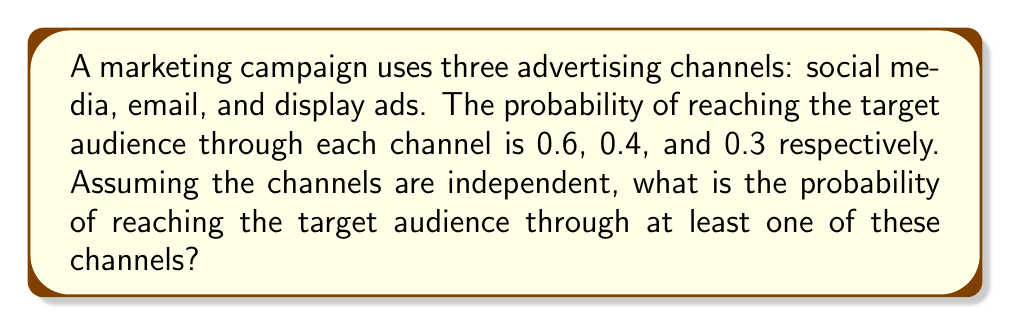Provide a solution to this math problem. Let's approach this step-by-step using the concept of probability of complementary events:

1) Let A be the event of reaching the target audience through at least one channel.
2) The complement of A is the event of not reaching the target audience through any channel.

3) Probability of not reaching through social media: $1 - 0.6 = 0.4$
4) Probability of not reaching through email: $1 - 0.4 = 0.6$
5) Probability of not reaching through display ads: $1 - 0.3 = 0.7$

6) Since the channels are independent, the probability of not reaching through any channel is:
   $$P(\text{not reaching}) = 0.4 \times 0.6 \times 0.7 = 0.168$$

7) Therefore, the probability of reaching through at least one channel is:
   $$P(A) = 1 - P(\text{not reaching}) = 1 - 0.168 = 0.832$$

8) This can be expressed as a percentage: $0.832 \times 100\% = 83.2\%$
Answer: $0.832$ or $83.2\%$ 